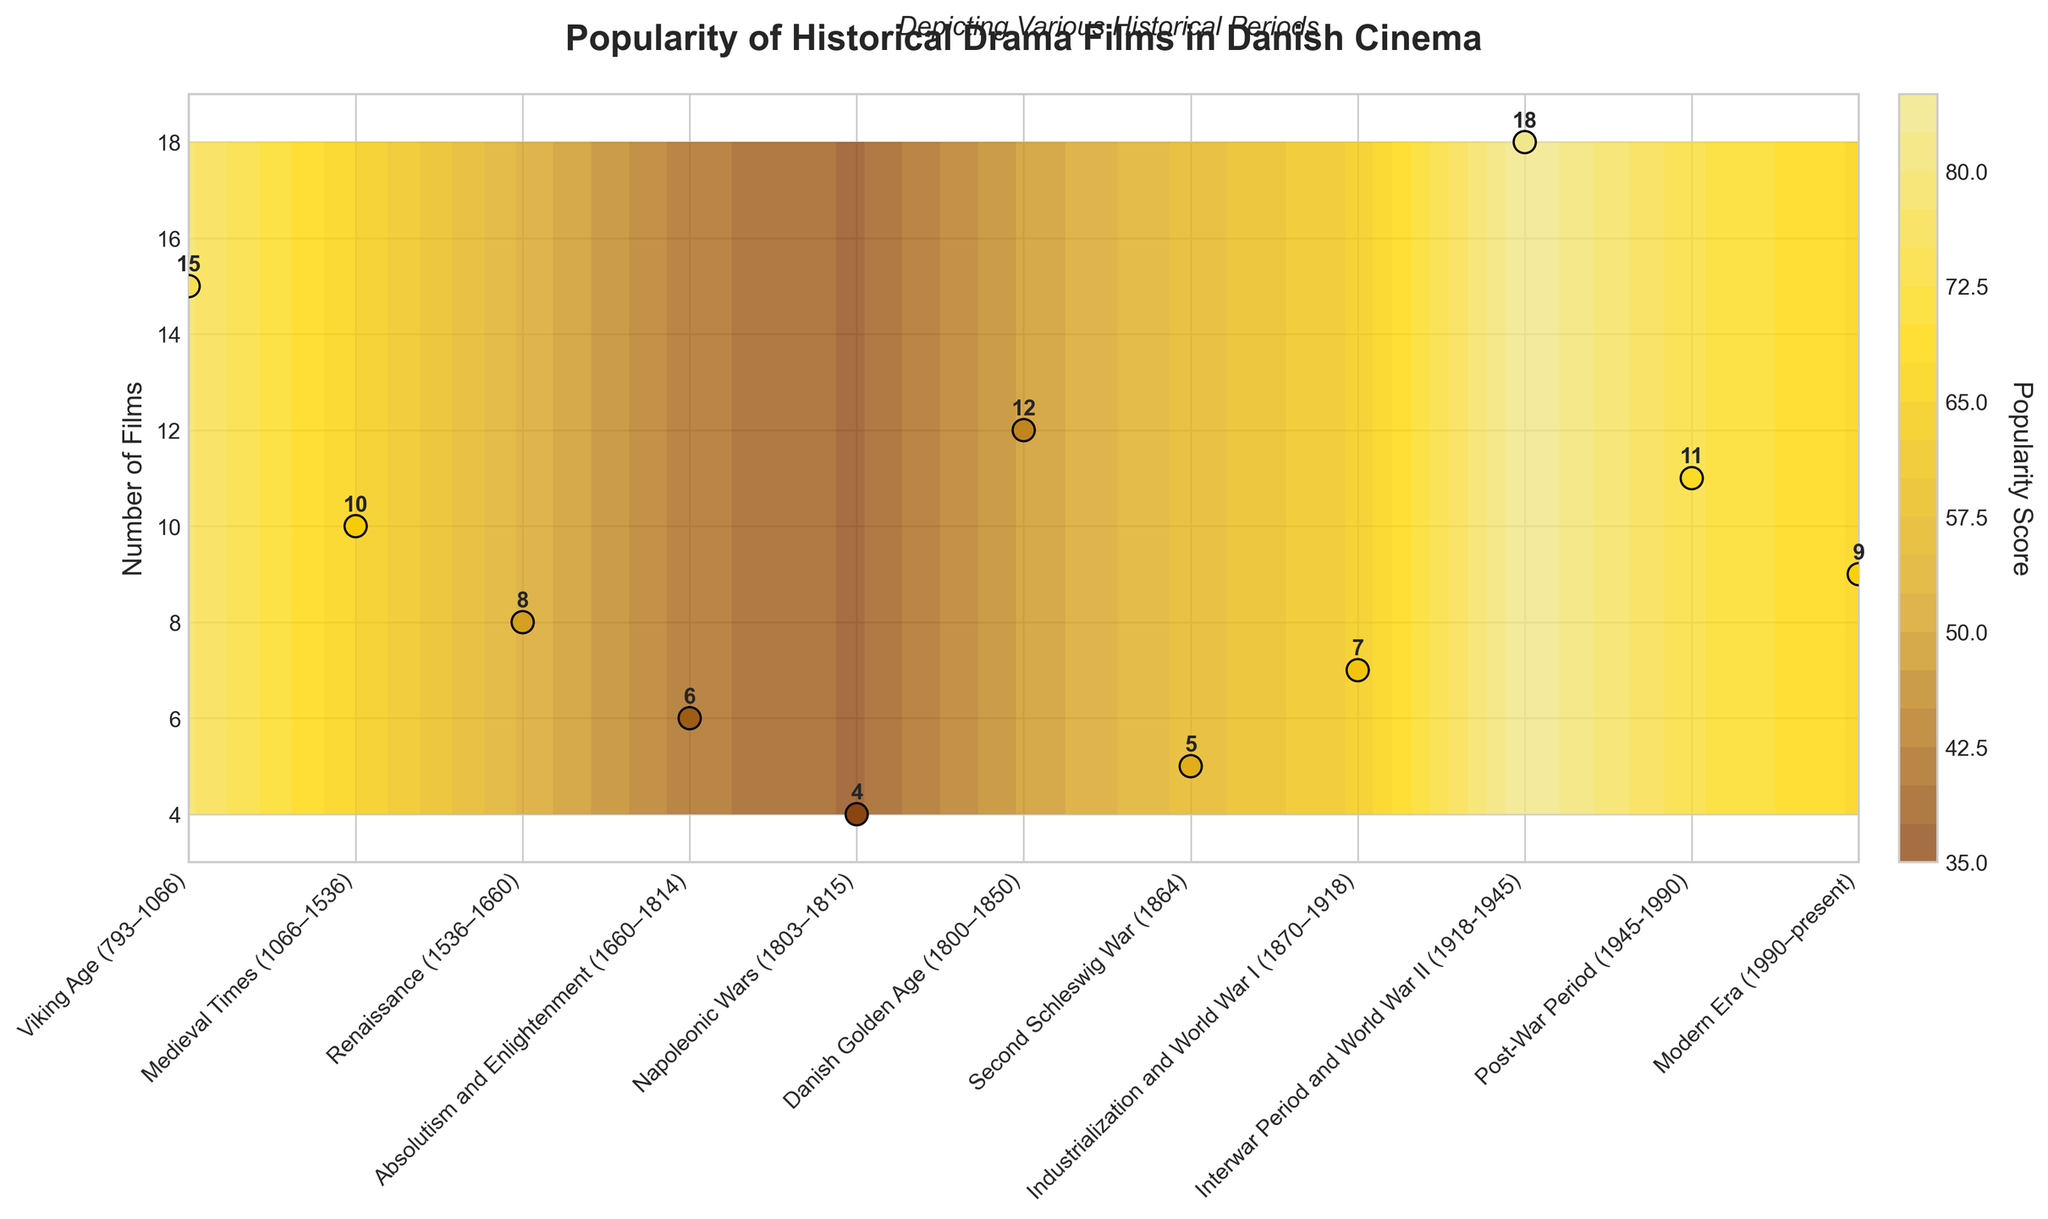What is the title of the plot? The title of the plot is displayed prominently at the top and reads "Popularity of Historical Drama Films in Danish Cinema." This title gives an overview of what the data visualization represents.
Answer: Popularity of Historical Drama Films in Danish Cinema Which historical period has the highest number of films? By examining the 'Number of Films' values on the y-axis and the corresponding labels on the x-axis, we see that the "Interwar Period and World War II (1918-1945)" has the highest number of films, indicated by a prominently annotated '18'.
Answer: Interwar Period and World War II (1918-1945) What is the range of the "Popularity Score" in the figure? The colorbar legend on the right side of the figure shows the range of the "Popularity Score". The range is indicated from the minimum score of 37 to the maximum score of 85.
Answer: 37 to 85 Which period has the highest popularity score and what is its value? The "Interwar Period and World War II (1918-1945)" has the highest popularity score, as shown in the color gradient and labeled values. The value is highlighted by the darkest color in the plot and the score '85' on the colorbar.
Answer: Interwar Period and World War II (1918-1945), 85 How many periods have a popularity score of 70 or higher? We need to identify the periods with popularity scores 70 and above by looking at each period's score annotated on the plot. These periods are "Viking Age (793–1066)" with 78, "Interwar Period and World War II (1918-1945)" with 85, and "Post-War Period (1945-1990)" with 73. There are three periods in total.
Answer: 3 What is the average number of films across all periods? Sum the number of films across all periods: 15 + 10 + 8 + 6 + 4 + 12 + 5 + 7 + 18 + 11 + 9 = 105. There are 11 periods. Average = 105 / 11 = 9.55 (rounded to 2 decimal places).
Answer: 9.55 Which period depicts the fewest number of films and what is the corresponding popularity score? The "Napoleonic Wars (1803–1815)" period has the fewest number of films with only 4 films, as shown by the smallest annotated data point on the y-axis. The corresponding popularity score for this period is 37, as indicated by the color gradient and annotation.
Answer: Napoleonic Wars (1803-1815), 37 Compare the popularity scores of "Viking Age (793–1066)" and "Medieval Times (1066–1536)". Which period is more popular? Looking at the annotated scores, "Viking Age (793–1066)" has a popularity score of 78, while "Medieval Times (1066–1536)" has a score of 65. Therefore, the "Viking Age" period is more popular.
Answer: Viking Age (793-1066) What is the general trend in the number of films produced from "Viking Age (793–1066)" to "Modern Era (1990–present)"? Observing the y-axis values from left (Viking Age) to right (Modern Era), the overall trend shows a fluctuation, with initial high numbers, dipping in the middle periods, peaking again around the Interwar Period and World War II, followed by another decline.
Answer: Fluctuating with peaks and dips What similarities can you find between the Danish Golden Age and the Post-War Period in terms of film production and popularity scores? The Danish Golden Age (1800-1850) produces 12 films with a popularity score of 48, while the Post-War Period (1945-1990) produces 11 films with a popularity score of 73. Both periods are relatively close in film count but have differing popularity scores, with the latter being much higher.
Answer: Similar number of films; differing popularity scores 